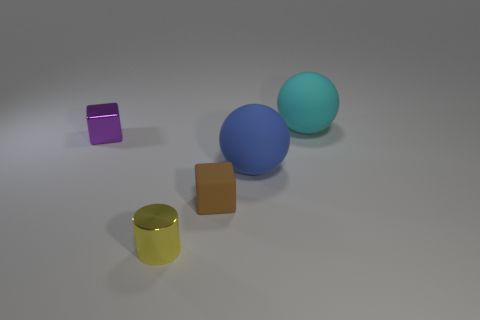Subtract all spheres. How many objects are left? 3 Add 3 big cyan balls. How many objects exist? 8 Add 3 tiny blue matte blocks. How many tiny blue matte blocks exist? 3 Subtract 0 yellow spheres. How many objects are left? 5 Subtract all red metallic cubes. Subtract all big cyan objects. How many objects are left? 4 Add 3 rubber blocks. How many rubber blocks are left? 4 